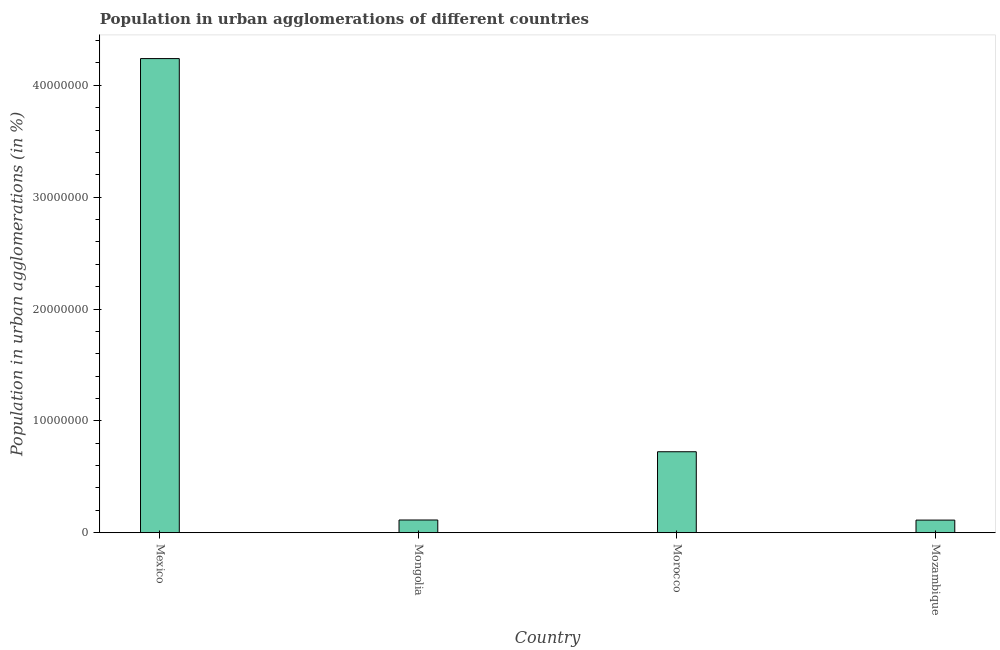Does the graph contain any zero values?
Offer a terse response. No. Does the graph contain grids?
Ensure brevity in your answer.  No. What is the title of the graph?
Offer a terse response. Population in urban agglomerations of different countries. What is the label or title of the X-axis?
Give a very brief answer. Country. What is the label or title of the Y-axis?
Provide a short and direct response. Population in urban agglomerations (in %). What is the population in urban agglomerations in Mozambique?
Give a very brief answer. 1.13e+06. Across all countries, what is the maximum population in urban agglomerations?
Your answer should be very brief. 4.24e+07. Across all countries, what is the minimum population in urban agglomerations?
Offer a very short reply. 1.13e+06. In which country was the population in urban agglomerations maximum?
Make the answer very short. Mexico. In which country was the population in urban agglomerations minimum?
Your answer should be compact. Mozambique. What is the sum of the population in urban agglomerations?
Offer a terse response. 5.19e+07. What is the difference between the population in urban agglomerations in Mongolia and Morocco?
Ensure brevity in your answer.  -6.10e+06. What is the average population in urban agglomerations per country?
Your response must be concise. 1.30e+07. What is the median population in urban agglomerations?
Make the answer very short. 4.19e+06. In how many countries, is the population in urban agglomerations greater than 22000000 %?
Your answer should be very brief. 1. What is the ratio of the population in urban agglomerations in Mexico to that in Mozambique?
Offer a very short reply. 37.6. Is the difference between the population in urban agglomerations in Mexico and Mozambique greater than the difference between any two countries?
Your answer should be compact. Yes. What is the difference between the highest and the second highest population in urban agglomerations?
Offer a very short reply. 3.52e+07. Is the sum of the population in urban agglomerations in Mexico and Mozambique greater than the maximum population in urban agglomerations across all countries?
Give a very brief answer. Yes. What is the difference between the highest and the lowest population in urban agglomerations?
Your answer should be compact. 4.13e+07. In how many countries, is the population in urban agglomerations greater than the average population in urban agglomerations taken over all countries?
Provide a short and direct response. 1. How many bars are there?
Your response must be concise. 4. Are all the bars in the graph horizontal?
Make the answer very short. No. What is the difference between two consecutive major ticks on the Y-axis?
Provide a succinct answer. 1.00e+07. What is the Population in urban agglomerations (in %) in Mexico?
Your answer should be compact. 4.24e+07. What is the Population in urban agglomerations (in %) of Mongolia?
Offer a terse response. 1.14e+06. What is the Population in urban agglomerations (in %) of Morocco?
Provide a succinct answer. 7.24e+06. What is the Population in urban agglomerations (in %) in Mozambique?
Your answer should be compact. 1.13e+06. What is the difference between the Population in urban agglomerations (in %) in Mexico and Mongolia?
Your response must be concise. 4.13e+07. What is the difference between the Population in urban agglomerations (in %) in Mexico and Morocco?
Provide a short and direct response. 3.52e+07. What is the difference between the Population in urban agglomerations (in %) in Mexico and Mozambique?
Make the answer very short. 4.13e+07. What is the difference between the Population in urban agglomerations (in %) in Mongolia and Morocco?
Offer a terse response. -6.10e+06. What is the difference between the Population in urban agglomerations (in %) in Mongolia and Mozambique?
Your response must be concise. 1.04e+04. What is the difference between the Population in urban agglomerations (in %) in Morocco and Mozambique?
Offer a very short reply. 6.11e+06. What is the ratio of the Population in urban agglomerations (in %) in Mexico to that in Mongolia?
Offer a terse response. 37.26. What is the ratio of the Population in urban agglomerations (in %) in Mexico to that in Morocco?
Provide a succinct answer. 5.86. What is the ratio of the Population in urban agglomerations (in %) in Mexico to that in Mozambique?
Provide a succinct answer. 37.6. What is the ratio of the Population in urban agglomerations (in %) in Mongolia to that in Morocco?
Your answer should be compact. 0.16. What is the ratio of the Population in urban agglomerations (in %) in Morocco to that in Mozambique?
Your answer should be very brief. 6.42. 